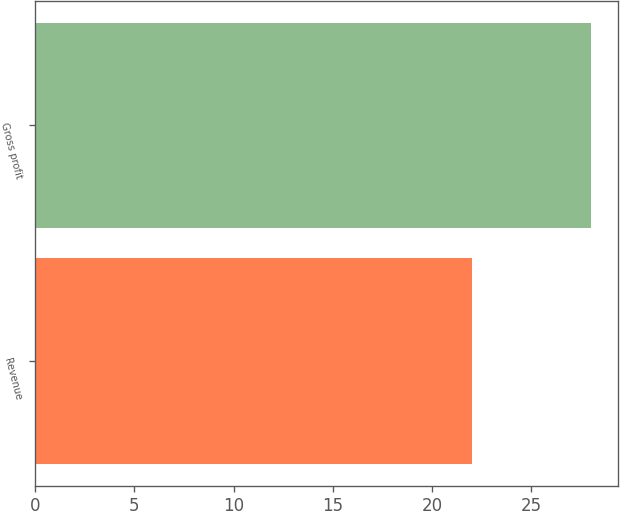<chart> <loc_0><loc_0><loc_500><loc_500><bar_chart><fcel>Revenue<fcel>Gross profit<nl><fcel>22<fcel>28<nl></chart> 